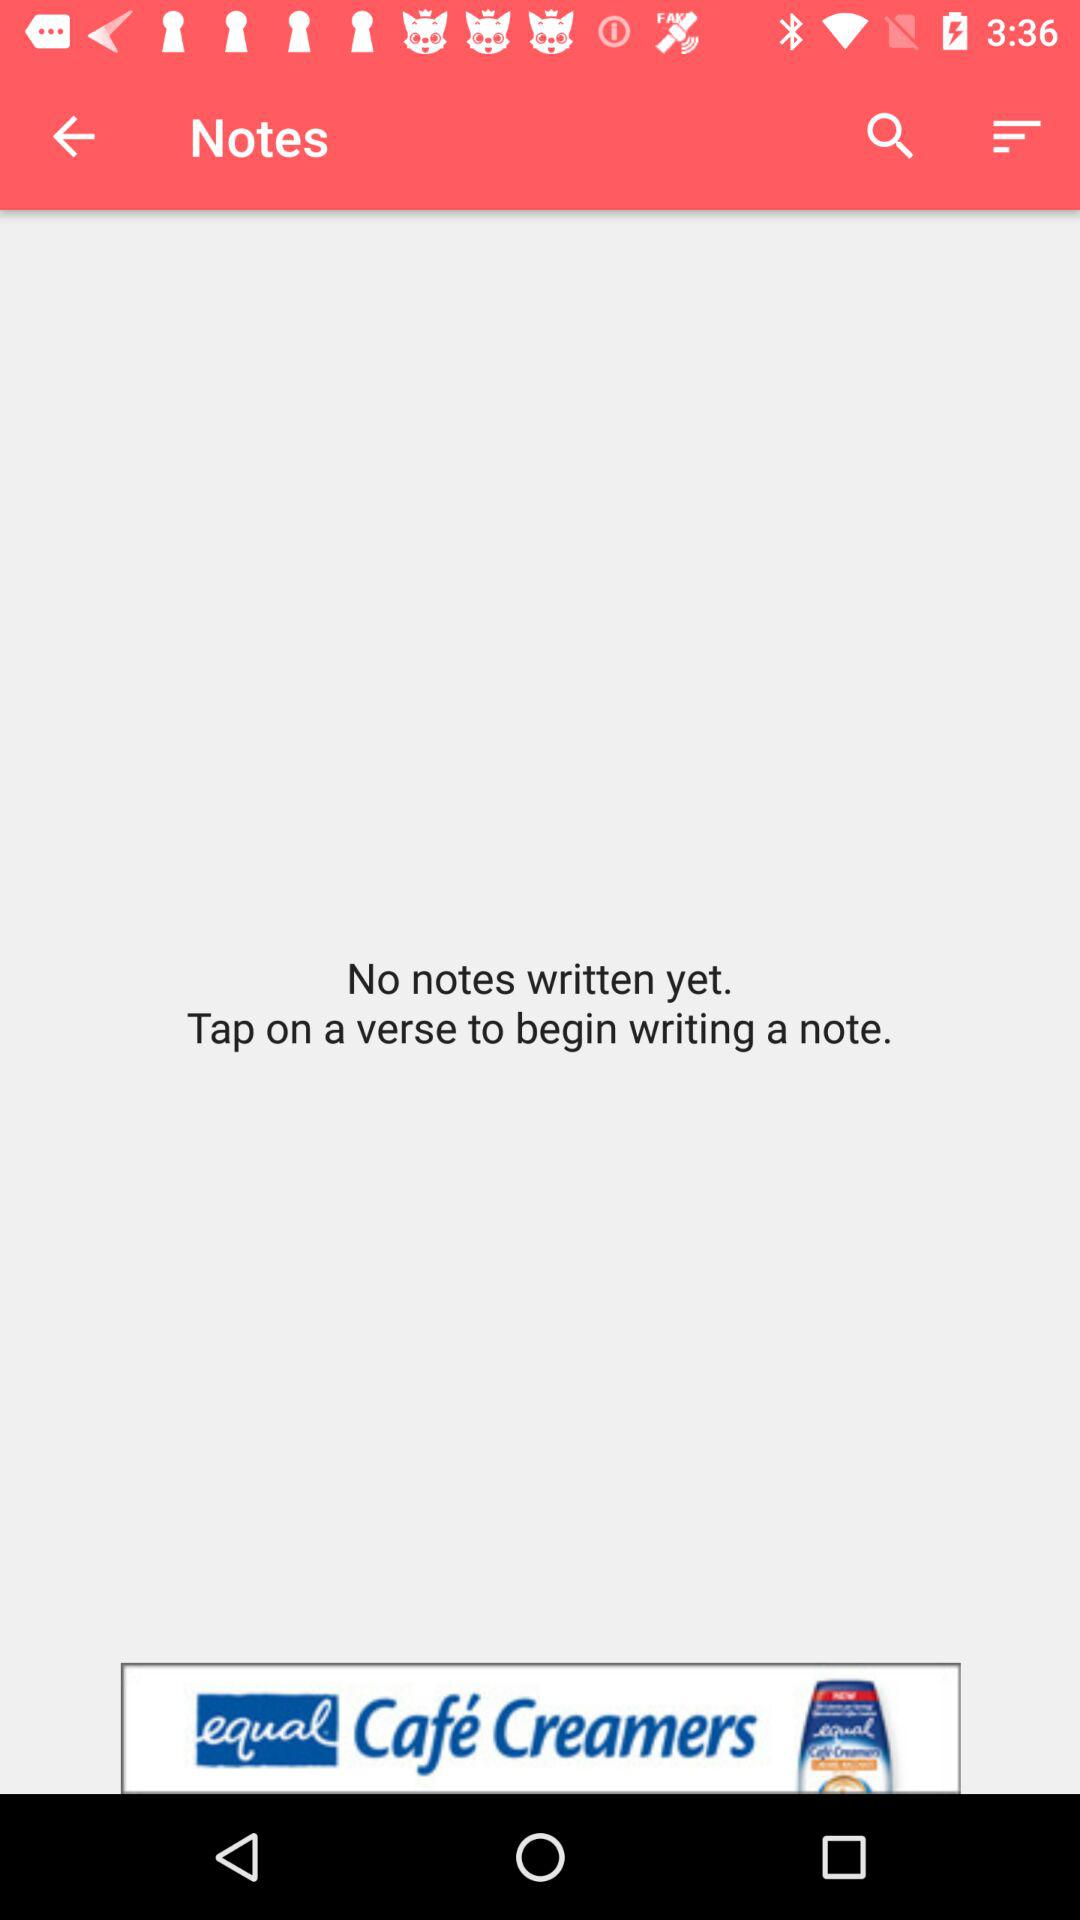Are there any notes written? There are no notes written yet. 